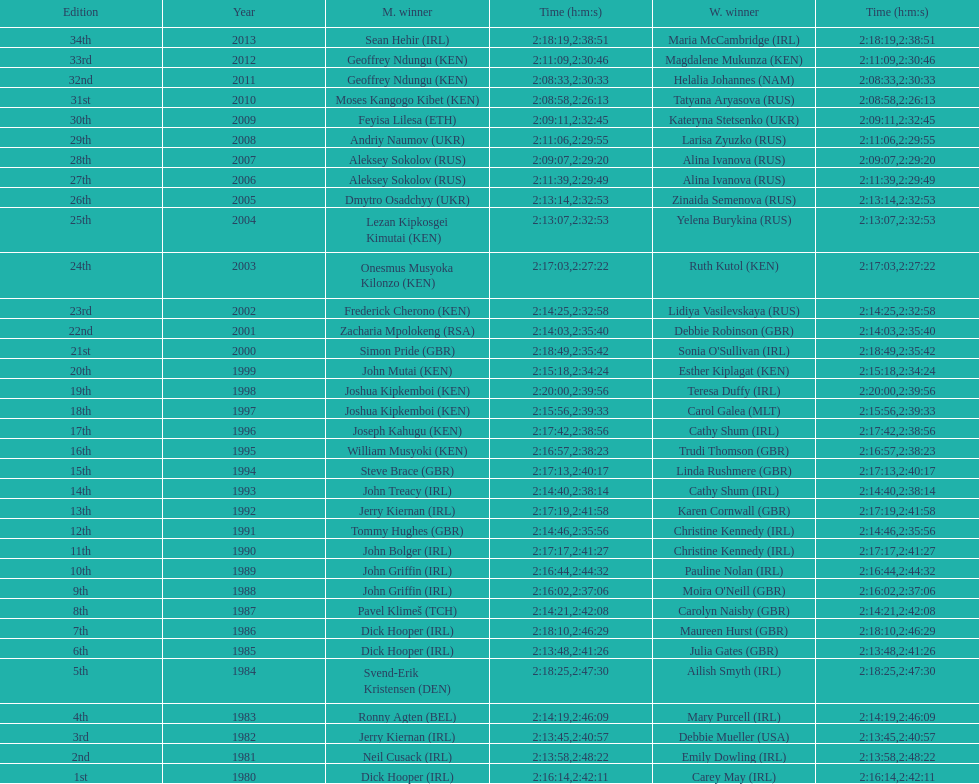Who won at least 3 times in the mens? Dick Hooper (IRL). 